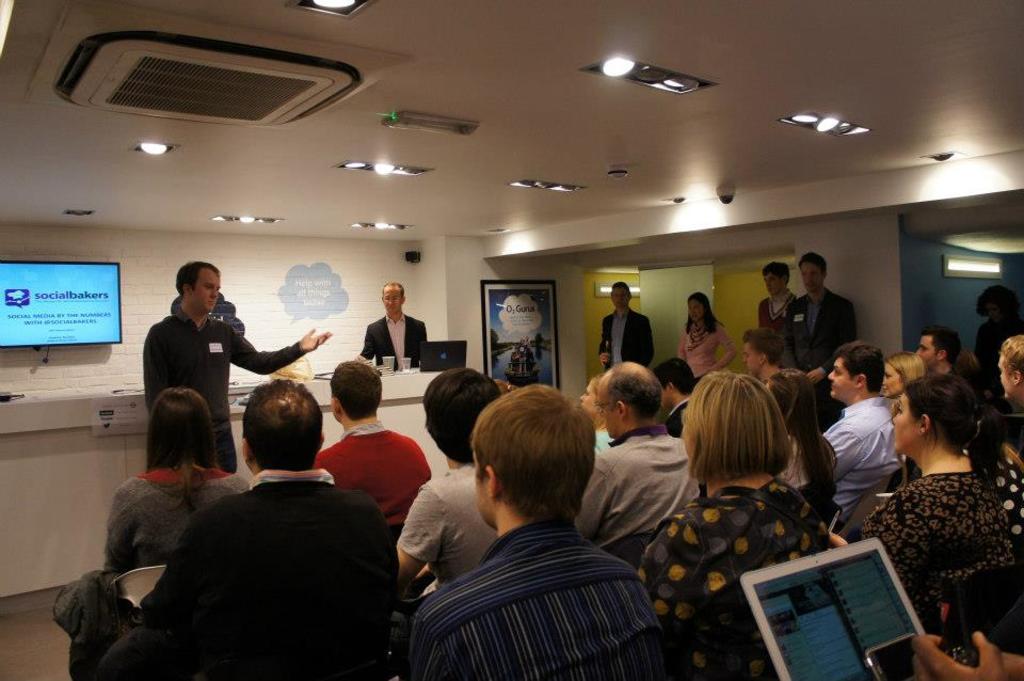Please provide a concise description of this image. In this image we can see these persons are sitting on the chairs and here we can see a laptop. Here we can see these persons are standing, we can see laptop and a few more things are kept on the table, we can see monitor, doors, air conditioner, CC camera and the ceiling lights. 